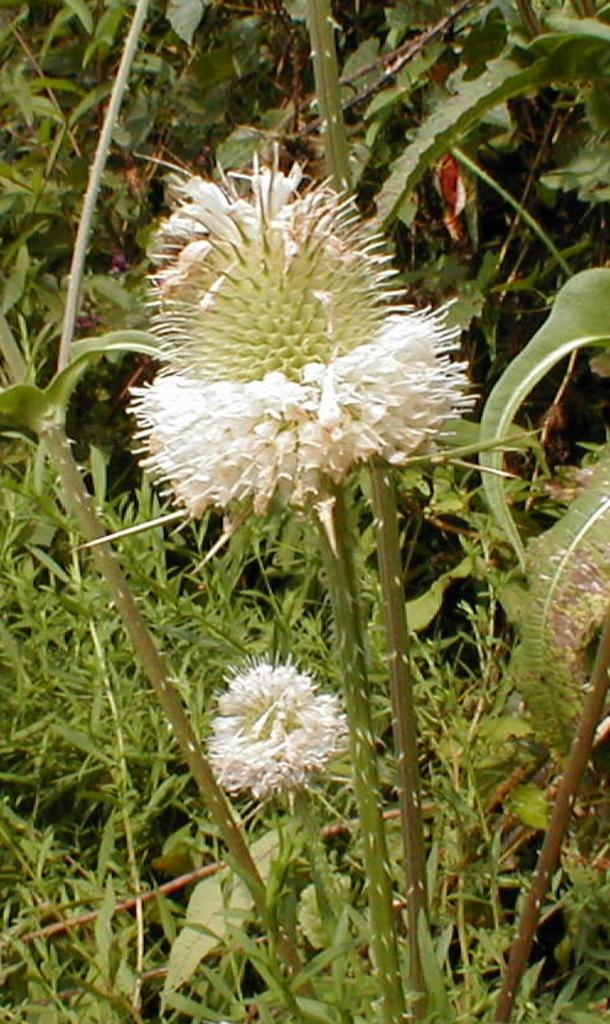What is the main subject in the center of the image? There is a flower plant in the center of the image. Can you describe the surrounding area in the image? There are other plants in the background of the image. How many tickets are attached to the van in the image? There is no van or tickets present in the image; it features a flower plant and other plants in the background. 